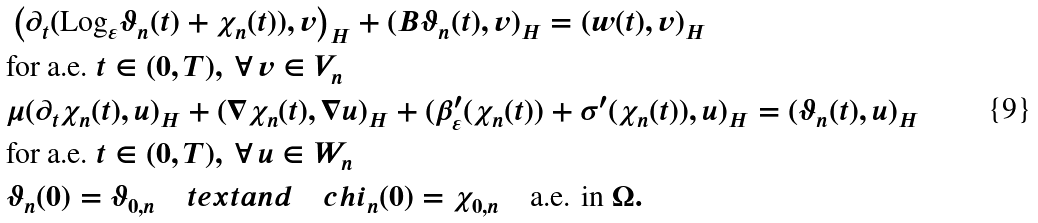<formula> <loc_0><loc_0><loc_500><loc_500>& \left ( \partial _ { t } ( \text {Log} _ { \varepsilon } \vartheta _ { n } ( t ) + \chi _ { n } ( t ) ) , v \right ) _ { H } + ( B \vartheta _ { n } ( t ) , v ) _ { H } = ( w ( t ) , v ) _ { H } \\ & \text {for a.e.} \ t \in ( 0 , T ) , \ \forall \, v \in V _ { n } \\ & \mu ( \partial _ { t } \chi _ { n } ( t ) , u ) _ { H } + ( \nabla \chi _ { n } ( t ) , \nabla u ) _ { H } + ( \beta ^ { \prime } _ { \varepsilon } ( \chi _ { n } ( t ) ) + \sigma ^ { \prime } ( \chi _ { n } ( t ) ) , u ) _ { H } = ( \vartheta _ { n } ( t ) , u ) _ { H } \\ & \text {for a.e.} \ t \in ( 0 , T ) , \ \forall \, u \in W _ { n } \\ & \vartheta _ { n } ( 0 ) = \vartheta _ { 0 , n } \quad t e x t { a n d } \quad c h i _ { n } ( 0 ) = \chi _ { 0 , n } \quad \text {a.e. in} \ \Omega .</formula> 